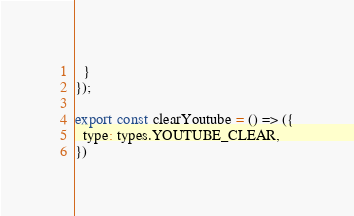Convert code to text. <code><loc_0><loc_0><loc_500><loc_500><_JavaScript_>  }
});

export const clearYoutube = () => ({
  type: types.YOUTUBE_CLEAR,
})</code> 